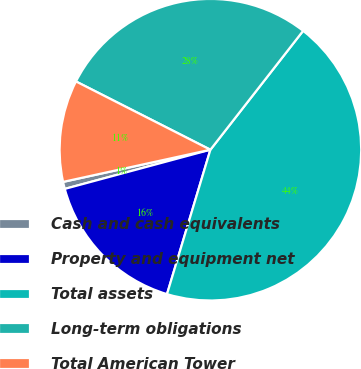<chart> <loc_0><loc_0><loc_500><loc_500><pie_chart><fcel>Cash and cash equivalents<fcel>Property and equipment net<fcel>Total assets<fcel>Long-term obligations<fcel>Total American Tower<nl><fcel>0.76%<fcel>16.17%<fcel>44.1%<fcel>28.06%<fcel>10.9%<nl></chart> 